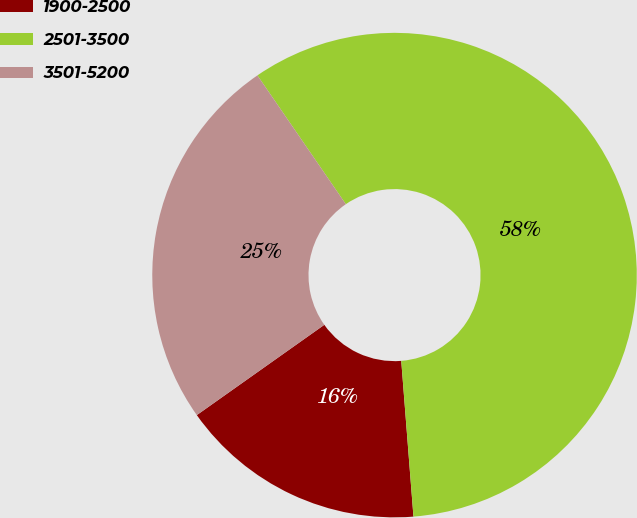<chart> <loc_0><loc_0><loc_500><loc_500><pie_chart><fcel>1900-2500<fcel>2501-3500<fcel>3501-5200<nl><fcel>16.44%<fcel>58.33%<fcel>25.23%<nl></chart> 